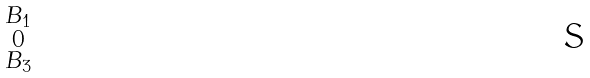Convert formula to latex. <formula><loc_0><loc_0><loc_500><loc_500>\begin{smallmatrix} B _ { 1 } \\ 0 \\ B _ { 3 } \end{smallmatrix}</formula> 